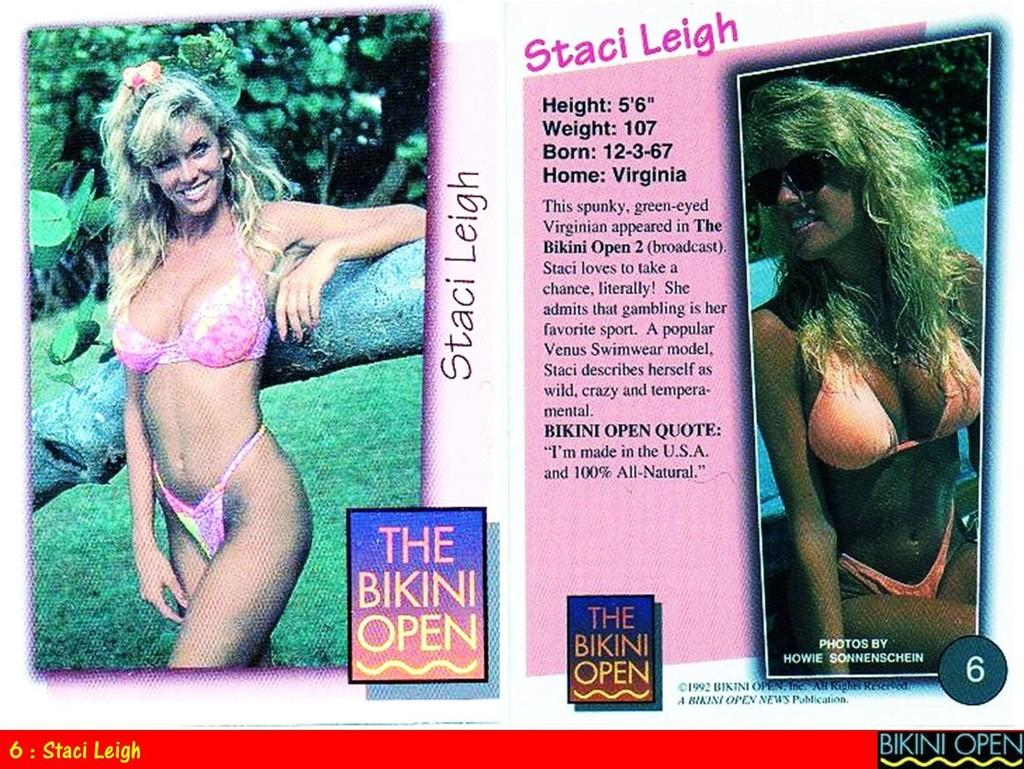What type of visual representation is the image? The image is a poster. How many images are present on the poster? There are two images on the poster. What other elements can be found on the poster besides the images? There are words and numbers on the poster. What type of dolls are playing during the recess in the image? There are no dolls or recess depicted in the image; it is a poster with two images, words, and numbers. 